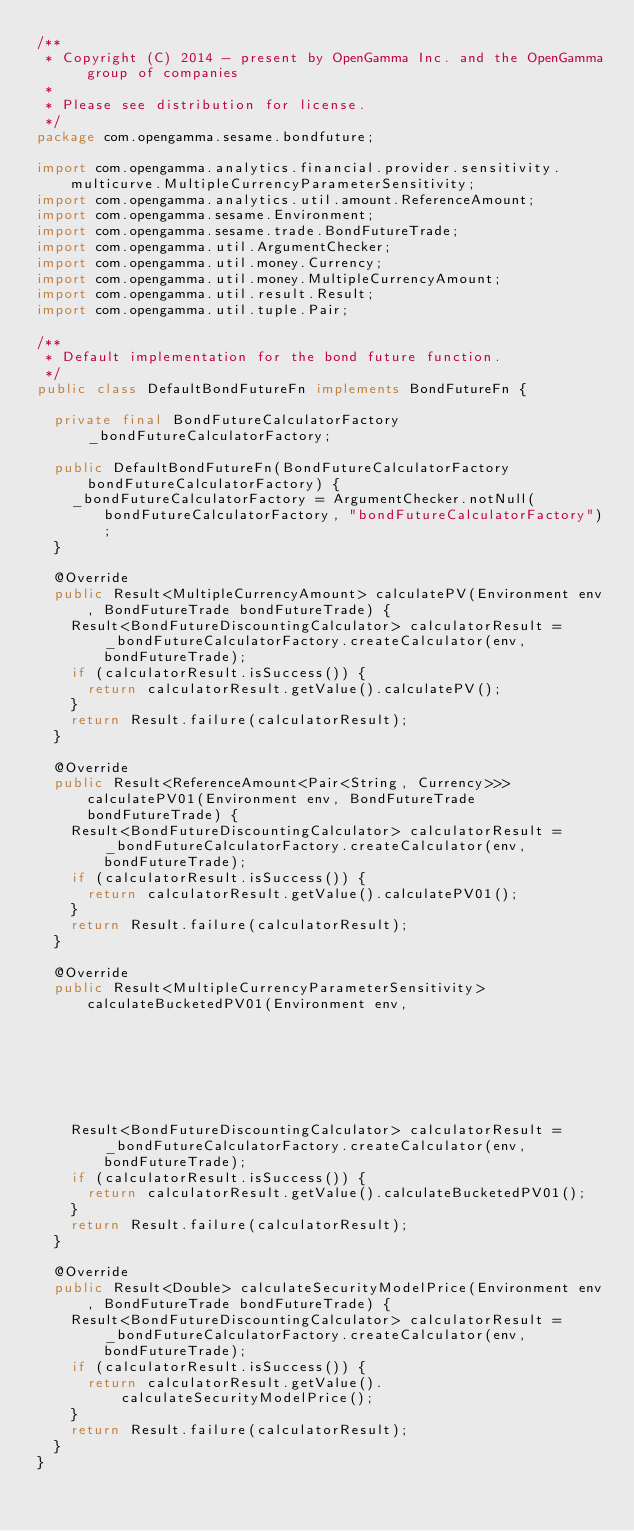<code> <loc_0><loc_0><loc_500><loc_500><_Java_>/**
 * Copyright (C) 2014 - present by OpenGamma Inc. and the OpenGamma group of companies
 *
 * Please see distribution for license.
 */
package com.opengamma.sesame.bondfuture;

import com.opengamma.analytics.financial.provider.sensitivity.multicurve.MultipleCurrencyParameterSensitivity;
import com.opengamma.analytics.util.amount.ReferenceAmount;
import com.opengamma.sesame.Environment;
import com.opengamma.sesame.trade.BondFutureTrade;
import com.opengamma.util.ArgumentChecker;
import com.opengamma.util.money.Currency;
import com.opengamma.util.money.MultipleCurrencyAmount;
import com.opengamma.util.result.Result;
import com.opengamma.util.tuple.Pair;

/**
 * Default implementation for the bond future function.
 */
public class DefaultBondFutureFn implements BondFutureFn {
  
  private final BondFutureCalculatorFactory _bondFutureCalculatorFactory;

  public DefaultBondFutureFn(BondFutureCalculatorFactory bondFutureCalculatorFactory) {
    _bondFutureCalculatorFactory = ArgumentChecker.notNull(bondFutureCalculatorFactory, "bondFutureCalculatorFactory");
  }
  
  @Override
  public Result<MultipleCurrencyAmount> calculatePV(Environment env, BondFutureTrade bondFutureTrade) {
    Result<BondFutureDiscountingCalculator> calculatorResult = _bondFutureCalculatorFactory.createCalculator(env, bondFutureTrade);
    if (calculatorResult.isSuccess()) {
      return calculatorResult.getValue().calculatePV();
    }
    return Result.failure(calculatorResult);
  }

  @Override
  public Result<ReferenceAmount<Pair<String, Currency>>> calculatePV01(Environment env, BondFutureTrade bondFutureTrade) {
    Result<BondFutureDiscountingCalculator> calculatorResult = _bondFutureCalculatorFactory.createCalculator(env, bondFutureTrade);
    if (calculatorResult.isSuccess()) {
      return calculatorResult.getValue().calculatePV01();
    }
    return Result.failure(calculatorResult);
  }

  @Override
  public Result<MultipleCurrencyParameterSensitivity> calculateBucketedPV01(Environment env,
                                                                            BondFutureTrade bondFutureTrade) {
    Result<BondFutureDiscountingCalculator> calculatorResult = _bondFutureCalculatorFactory.createCalculator(env, bondFutureTrade);
    if (calculatorResult.isSuccess()) {
      return calculatorResult.getValue().calculateBucketedPV01();
    }
    return Result.failure(calculatorResult);
  }

  @Override
  public Result<Double> calculateSecurityModelPrice(Environment env, BondFutureTrade bondFutureTrade) {
    Result<BondFutureDiscountingCalculator> calculatorResult = _bondFutureCalculatorFactory.createCalculator(env, bondFutureTrade);
    if (calculatorResult.isSuccess()) {
      return calculatorResult.getValue().calculateSecurityModelPrice();
    }
    return Result.failure(calculatorResult);
  }
}
</code> 